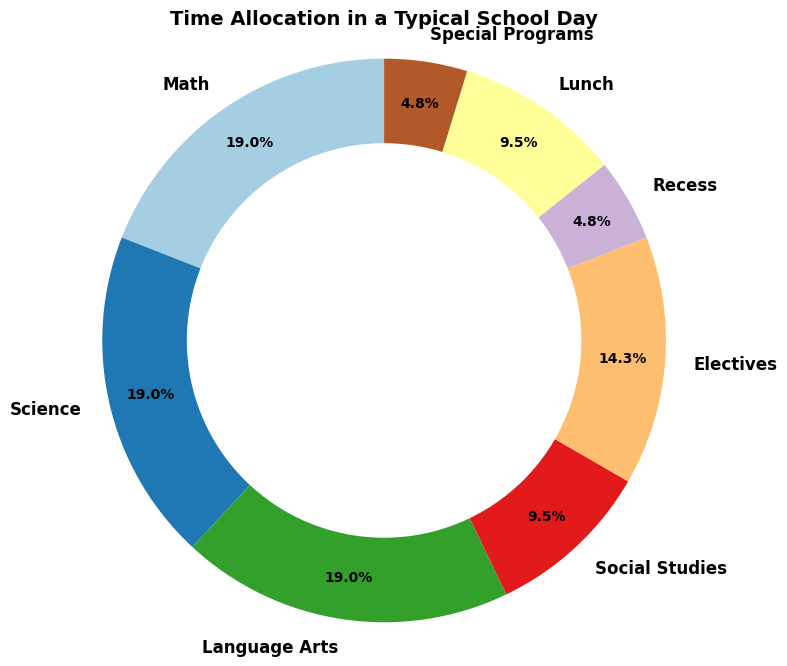Which subject takes up the most time in a typical school day? The figure shows a ring chart with different segments representing different subjects. The segment with the largest area indicates the subject that takes up the most time.
Answer: Math, Science, and Language Arts each have 2 hours What is the total time allocated to core subjects? Core subjects include Math, Science, Language Arts, and Social Studies. So, we sum up their hours: 2 (Math) + 2 (Science) + 2 (Language Arts) + 1 (Social Studies) = 7 hours.
Answer: 7 hours How much more time is allocated to Math compared to Recess? The figure indicates that Math is allocated 2 hours and Recess is allocated 0.5 hours. The difference is calculated by subtracting 0.5 from 2: 2 - 0.5 = 1.5 hours.
Answer: 1.5 hours Which activity gets equal time allocation as Recess? Recess is given 0.5 hours. By looking at the chart, the segment marked "Special Programs" also has 0.5 hours, which is the same as Recess.
Answer: Special Programs How does the time for Lunch compare to the time for Electives? Lunch is allocated 1 hour, and Electives are allocated 1.5 hours. Therefore, Electives get 0.5 hours more time than Lunch.
Answer: Electives get 0.5 hours more than Lunch What percentage of the school day is spent on Lunch and Recess combined? Lunch takes 1 hour and Recess takes 0.5 hours. The combined time is 1 + 0.5 = 1.5 hours. To find the percentage, divide the combined time by the total school day time (8 hours), then multiply by 100: (1.5 / 8) * 100 = 18.75%.
Answer: 18.75% Which subject or activity takes up the smallest portion of the school day? The figure shows segments of various sizes, and the smallest segment corresponds to the activity with the least time allocation. Both Recess and Special Programs have the smallest segment with 0.5 hours each.
Answer: Recess and Special Programs Is the time spent on Electives greater than the time spent on Science? By examining the chart, Electives are 1.5 hours and Science is 2 hours. Since 1.5 is less than 2, the time spent on Electives is not greater than the time spent on Science.
Answer: No How many more hours are spent on core subjects compared to all other activities combined? Core subjects take 7 hours in total. Other activities include Electives (1.5), Recess (0.5), Lunch (1), and Special Programs (0.5). The total for other activities is 3.5 hours. The difference is 7 - 3.5 = 3.5 hours.
Answer: 3.5 hours 